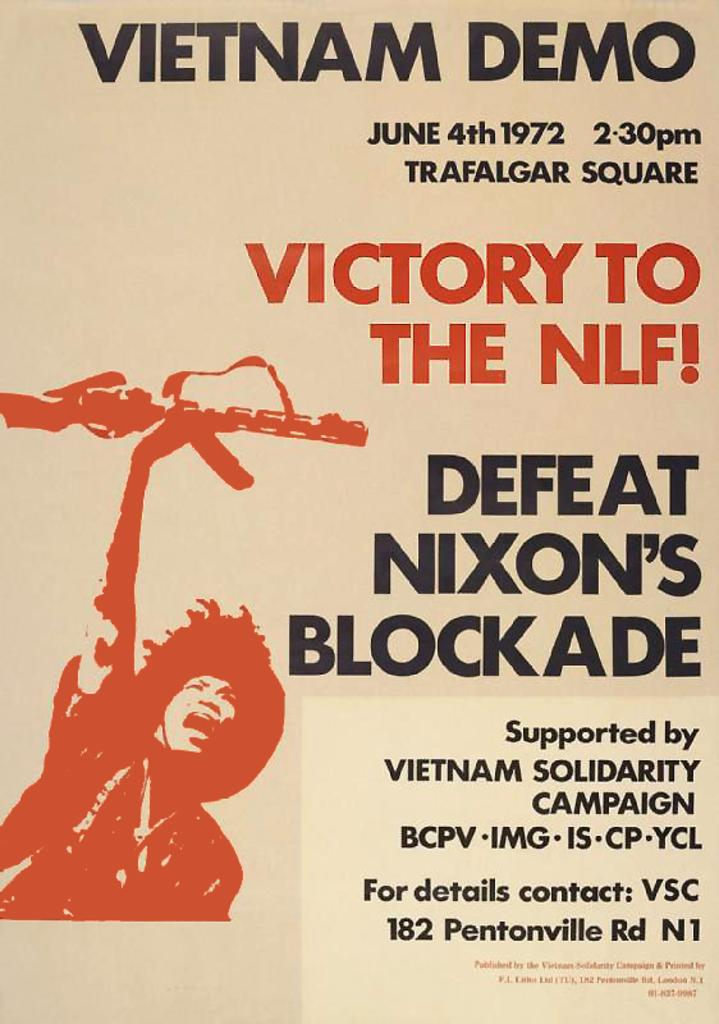<image>
Share a concise interpretation of the image provided. a poster against nixons blockade by the vietnam solidarity 